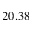<formula> <loc_0><loc_0><loc_500><loc_500>2 0 . 3 8</formula> 